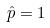Convert formula to latex. <formula><loc_0><loc_0><loc_500><loc_500>\hat { p } = 1</formula> 